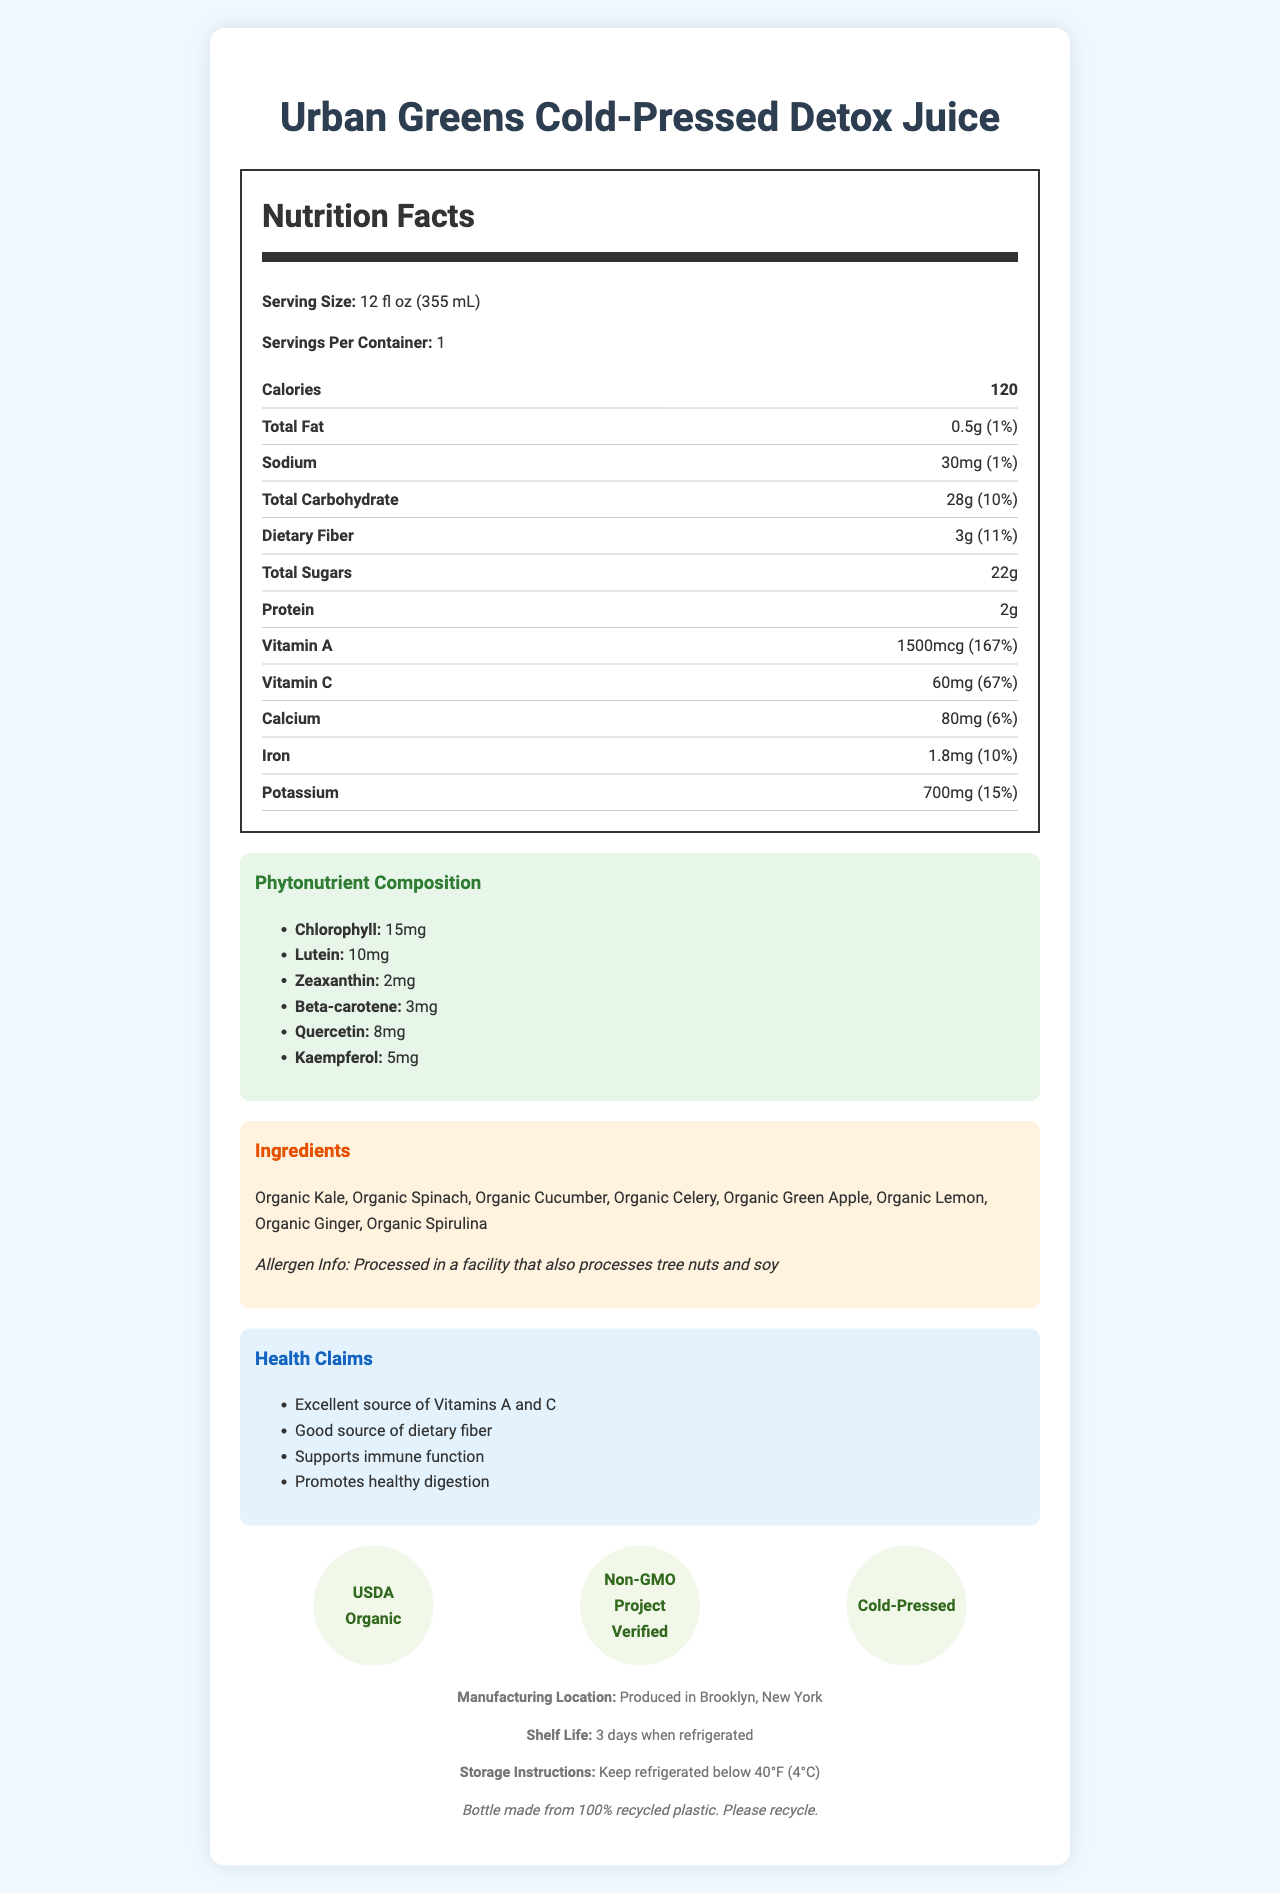what is the serving size for the Urban Greens Cold-Pressed Detox Juice? The serving size is explicitly mentioned in the Nutrition Facts section.
Answer: 12 fl oz (355 mL) how many calories are in one serving of the juice? The document states that each serving contains 120 calories.
Answer: 120 which vitamin is provided at 167% daily value in this juice? The document lists Vitamin A with a daily value of 167%.
Answer: Vitamin A what is the amount of dietary fiber per serving? The amount of dietary fiber per serving is provided as 3g in the Nutrition Facts.
Answer: 3g what is one of the phytonutrients found in the juice? Chlorophyll is listed under the phytonutrient composition in the document.
Answer: Chlorophyll how many milligrams of potassium does this juice contain? A. 300mg B. 500mg C. 700mg D. 900mg The juice contains 700mg of potassium per serving as mentioned in the Nutrition Facts.
Answer: C. 700mg which certification does this product have? A. USDA Organic B. Non-GMO Project Verified C. Both D. Neither The document lists both USDA Organic and Non-GMO Project Verified as certifications.
Answer: C. Both is the juice processed in a facility that processes tree nuts and soy? The allergen information states that it is processed in a facility that processes tree nuts and soy.
Answer: Yes can the recycling information of the bottle be found within the document? The recycling info is provided at the bottom of the document stating the bottle is made from 100% recycled plastic.
Answer: Yes describe the main idea of the Urban Greens Cold-Pressed Detox Juice document. The document thoroughly outlines the nutritional properties and health claims of the juice, highlighting its composition, benefits, and usage guidelines.
Answer: The document provides detailed nutritional information, including calorie count, vitamins, minerals, and phytonutrient composition for Urban Greens Cold-Pressed Detox Juice. It also lists ingredients, allergen information, health claims, certifications, and storage instructions. how much Vitamin E is present in the juice? Vitamin E is not mentioned in the nutrient composition list provided in the document.
Answer: Cannot be determined 